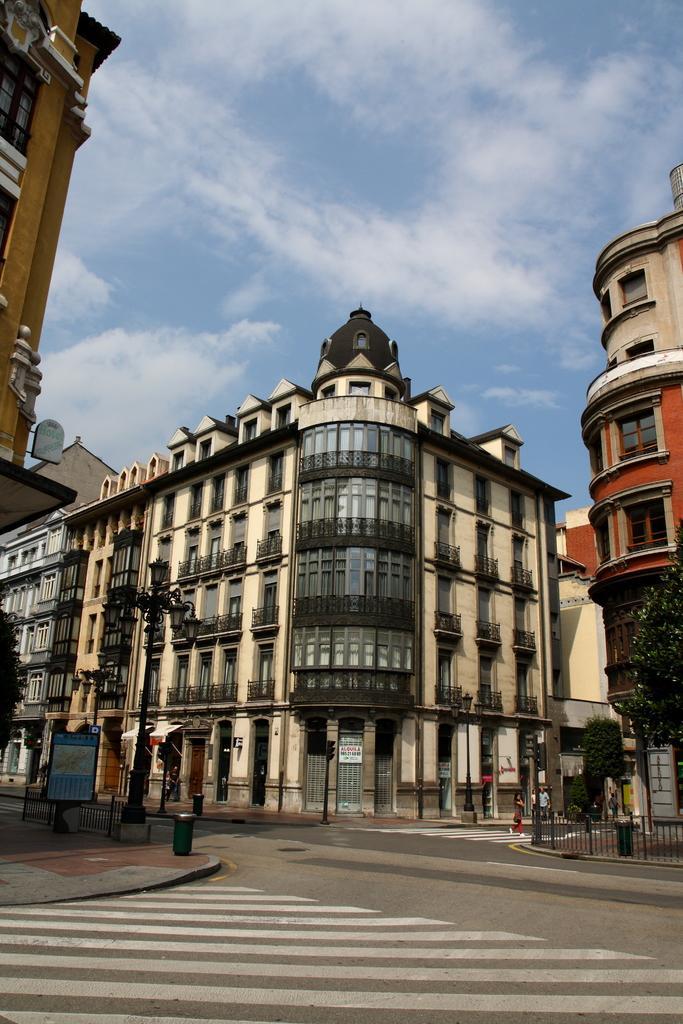Please provide a concise description of this image. In this image, I can see buildings, road and lights to a pole. At the bottom right side of the image, I can see two persons, iron grilles and trees. In the background, there is the sky. 